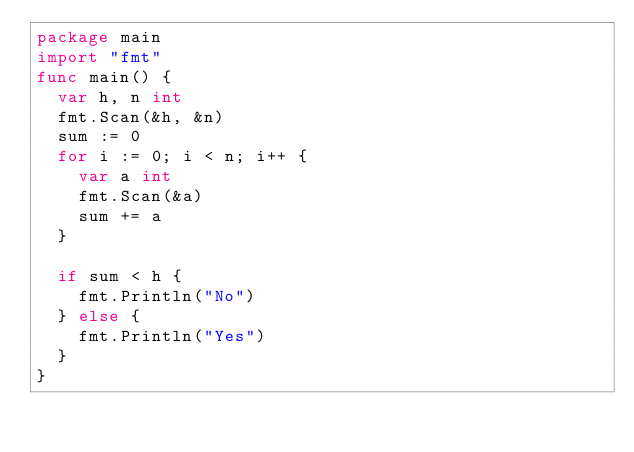Convert code to text. <code><loc_0><loc_0><loc_500><loc_500><_Go_>package main
import "fmt"
func main() {
  var h, n int
  fmt.Scan(&h, &n)
  sum := 0
  for i := 0; i < n; i++ {
    var a int
    fmt.Scan(&a)
    sum += a
  }
  
  if sum < h {
    fmt.Println("No")
  } else {
    fmt.Println("Yes")
  }
}</code> 